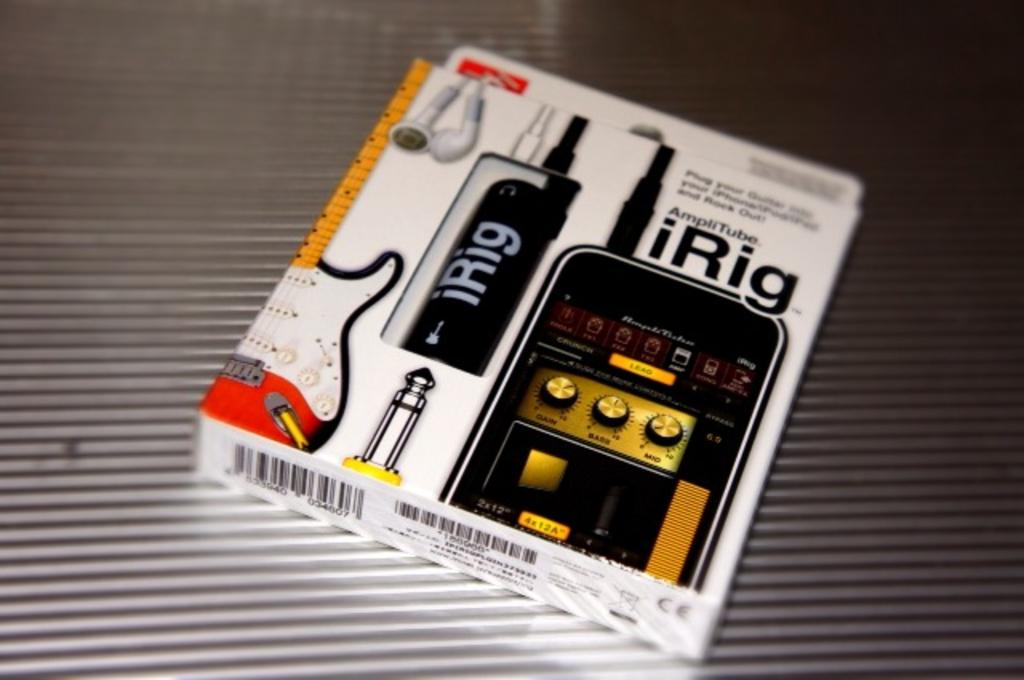<image>
Summarize the visual content of the image. IRig is a device that can turn an iPhone into a guitar accessory. 